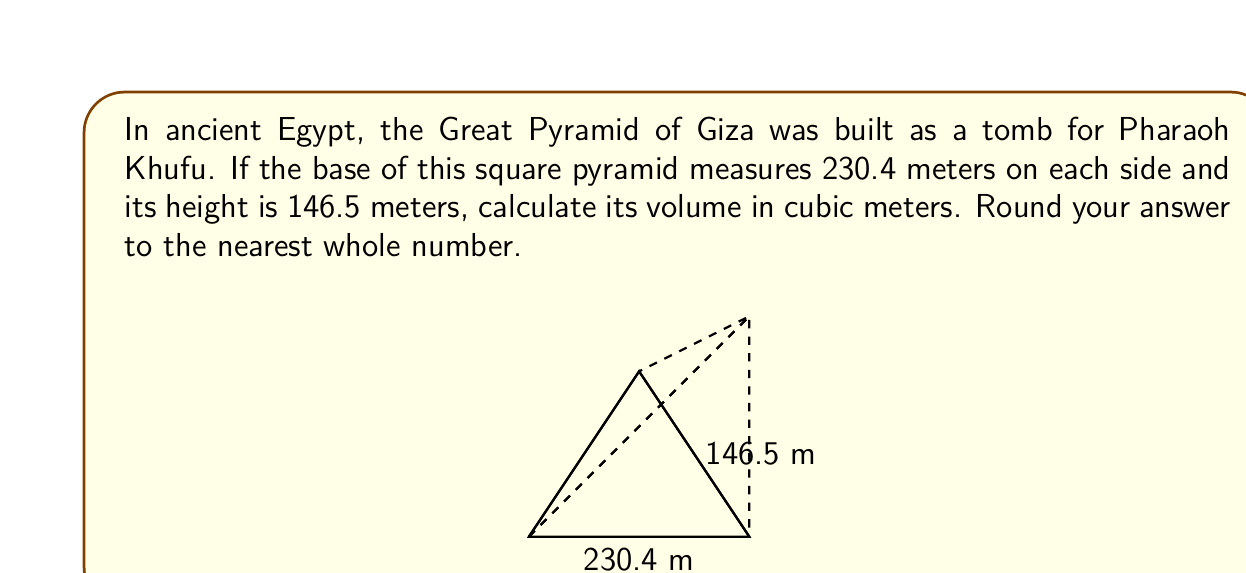Solve this math problem. Let's approach this step-by-step:

1) The volume of a pyramid is given by the formula:

   $$V = \frac{1}{3} \times B \times h$$

   where $V$ is the volume, $B$ is the area of the base, and $h$ is the height.

2) We need to calculate the area of the base first. The base is a square with side length 230.4 m. So:

   $$B = 230.4 \text{ m} \times 230.4 \text{ m} = 53,084.16 \text{ m}^2$$

3) Now we can substitute the values into our volume formula:

   $$V = \frac{1}{3} \times 53,084.16 \text{ m}^2 \times 146.5 \text{ m}$$

4) Let's calculate:

   $$V = 2,583,283.12 \text{ m}^3$$

5) Rounding to the nearest whole number:

   $$V \approx 2,583,283 \text{ m}^3$$

This volume represents the space enclosed by the Great Pyramid, which is a testament to the advanced architectural and mathematical knowledge of ancient Egyptians.
Answer: 2,583,283 m³ 